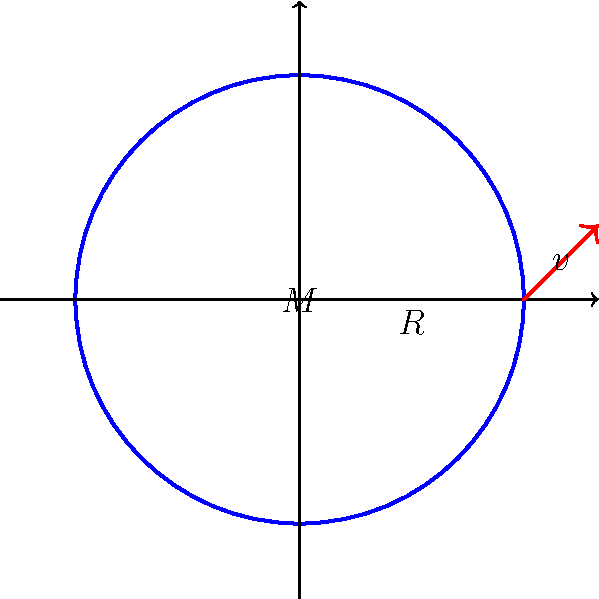As an innovative start-up inventor pushing the boundaries of science, you're developing a revolutionary space exploration technology. To ensure your spacecraft can escape a newly discovered exoplanet's gravitational pull, you need to calculate its escape velocity. Given that the exoplanet has a mass (M) of $5.2 \times 10^{24}$ kg and a radius (R) of $6.1 \times 10^6$ m, what is the escape velocity (v) from its surface? Use the escape velocity formula: $v = \sqrt{\frac{2GM}{R}}$, where G is the gravitational constant ($6.67 \times 10^{-11}$ N⋅m²/kg²). To calculate the escape velocity, we'll use the formula:

$v = \sqrt{\frac{2GM}{R}}$

Let's break it down step-by-step:

1. Given values:
   - Mass (M) = $5.2 \times 10^{24}$ kg
   - Radius (R) = $6.1 \times 10^6$ m
   - Gravitational constant (G) = $6.67 \times 10^{-11}$ N⋅m²/kg²

2. Substitute these values into the formula:
   $v = \sqrt{\frac{2 \times (6.67 \times 10^{-11}) \times (5.2 \times 10^{24})}{6.1 \times 10^6}}$

3. Simplify inside the square root:
   $v = \sqrt{\frac{69.3680 \times 10^{13}}{6.1 \times 10^6}}$

4. Divide inside the square root:
   $v = \sqrt{11.3719 \times 10^7}$

5. Calculate the square root:
   $v = 10,664.2$ m/s

6. Round to three significant figures:
   $v \approx 10,700$ m/s or 10.7 km/s

This escape velocity is crucial for your spacecraft design, ensuring it can break free from the exoplanet's gravitational field and continue its interstellar journey.
Answer: 10.7 km/s 